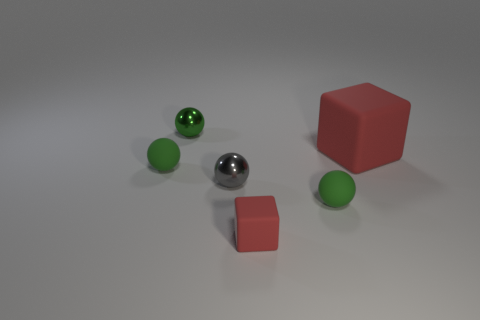Subtract all green spheres. How many spheres are left? 1 Subtract all yellow balls. Subtract all cyan cubes. How many balls are left? 4 Add 6 big matte objects. How many big matte objects exist? 7 Add 4 big red rubber things. How many objects exist? 10 Subtract all green spheres. How many spheres are left? 1 Subtract 0 purple balls. How many objects are left? 6 Subtract all cubes. How many objects are left? 4 Subtract 1 spheres. How many spheres are left? 3 Subtract all yellow cylinders. How many green spheres are left? 3 Subtract all small blue metal balls. Subtract all large red things. How many objects are left? 5 